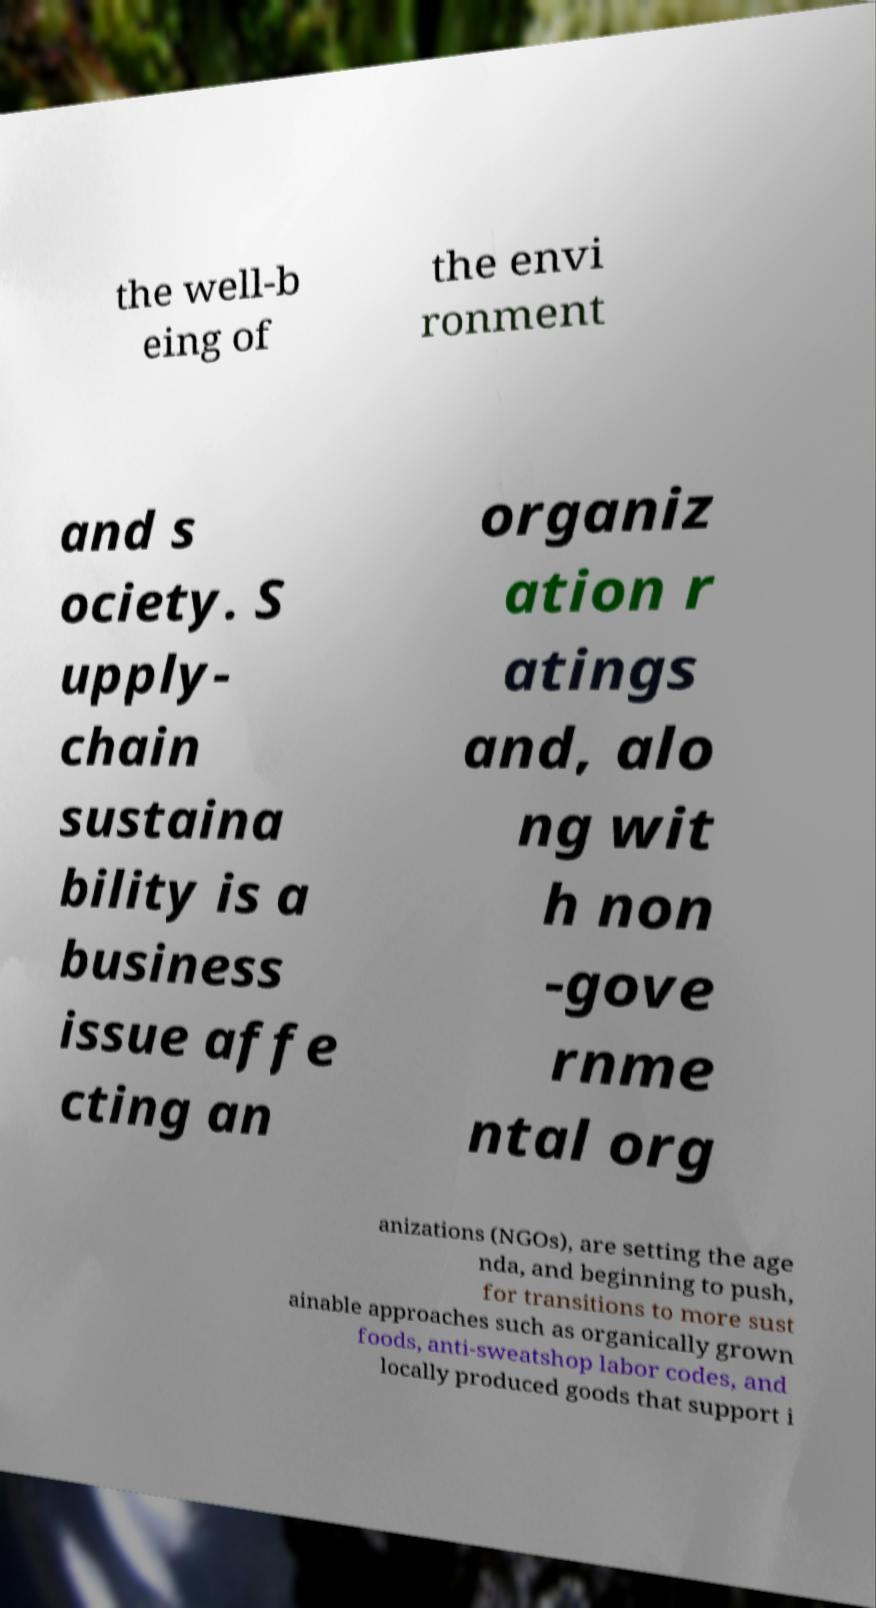For documentation purposes, I need the text within this image transcribed. Could you provide that? the well-b eing of the envi ronment and s ociety. S upply- chain sustaina bility is a business issue affe cting an organiz ation r atings and, alo ng wit h non -gove rnme ntal org anizations (NGOs), are setting the age nda, and beginning to push, for transitions to more sust ainable approaches such as organically grown foods, anti-sweatshop labor codes, and locally produced goods that support i 